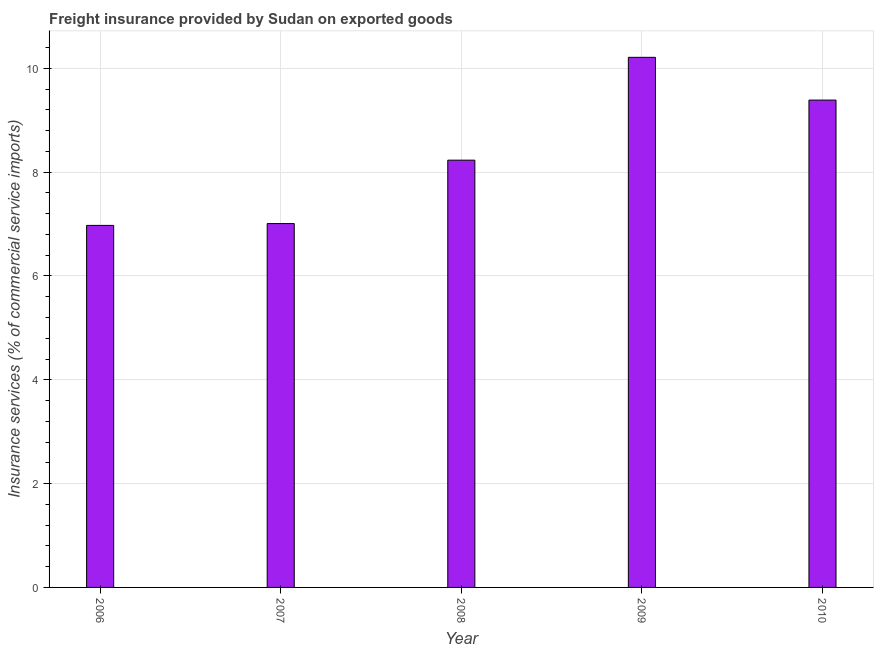Does the graph contain any zero values?
Provide a succinct answer. No. Does the graph contain grids?
Your response must be concise. Yes. What is the title of the graph?
Give a very brief answer. Freight insurance provided by Sudan on exported goods . What is the label or title of the Y-axis?
Give a very brief answer. Insurance services (% of commercial service imports). What is the freight insurance in 2008?
Your response must be concise. 8.23. Across all years, what is the maximum freight insurance?
Provide a short and direct response. 10.21. Across all years, what is the minimum freight insurance?
Your answer should be compact. 6.97. In which year was the freight insurance maximum?
Provide a short and direct response. 2009. In which year was the freight insurance minimum?
Keep it short and to the point. 2006. What is the sum of the freight insurance?
Offer a very short reply. 41.81. What is the difference between the freight insurance in 2009 and 2010?
Offer a very short reply. 0.82. What is the average freight insurance per year?
Offer a terse response. 8.36. What is the median freight insurance?
Your answer should be very brief. 8.23. Do a majority of the years between 2009 and 2007 (inclusive) have freight insurance greater than 5.6 %?
Provide a short and direct response. Yes. What is the ratio of the freight insurance in 2009 to that in 2010?
Ensure brevity in your answer.  1.09. What is the difference between the highest and the second highest freight insurance?
Keep it short and to the point. 0.82. Is the sum of the freight insurance in 2008 and 2010 greater than the maximum freight insurance across all years?
Your response must be concise. Yes. What is the difference between the highest and the lowest freight insurance?
Make the answer very short. 3.24. In how many years, is the freight insurance greater than the average freight insurance taken over all years?
Offer a very short reply. 2. How many bars are there?
Provide a succinct answer. 5. Are all the bars in the graph horizontal?
Provide a succinct answer. No. What is the difference between two consecutive major ticks on the Y-axis?
Give a very brief answer. 2. What is the Insurance services (% of commercial service imports) in 2006?
Make the answer very short. 6.97. What is the Insurance services (% of commercial service imports) of 2007?
Give a very brief answer. 7.01. What is the Insurance services (% of commercial service imports) in 2008?
Make the answer very short. 8.23. What is the Insurance services (% of commercial service imports) in 2009?
Provide a succinct answer. 10.21. What is the Insurance services (% of commercial service imports) in 2010?
Offer a terse response. 9.39. What is the difference between the Insurance services (% of commercial service imports) in 2006 and 2007?
Make the answer very short. -0.04. What is the difference between the Insurance services (% of commercial service imports) in 2006 and 2008?
Your answer should be compact. -1.26. What is the difference between the Insurance services (% of commercial service imports) in 2006 and 2009?
Your answer should be compact. -3.24. What is the difference between the Insurance services (% of commercial service imports) in 2006 and 2010?
Ensure brevity in your answer.  -2.41. What is the difference between the Insurance services (% of commercial service imports) in 2007 and 2008?
Keep it short and to the point. -1.22. What is the difference between the Insurance services (% of commercial service imports) in 2007 and 2009?
Offer a very short reply. -3.2. What is the difference between the Insurance services (% of commercial service imports) in 2007 and 2010?
Ensure brevity in your answer.  -2.38. What is the difference between the Insurance services (% of commercial service imports) in 2008 and 2009?
Your response must be concise. -1.98. What is the difference between the Insurance services (% of commercial service imports) in 2008 and 2010?
Provide a short and direct response. -1.16. What is the difference between the Insurance services (% of commercial service imports) in 2009 and 2010?
Offer a very short reply. 0.82. What is the ratio of the Insurance services (% of commercial service imports) in 2006 to that in 2007?
Make the answer very short. 0.99. What is the ratio of the Insurance services (% of commercial service imports) in 2006 to that in 2008?
Your answer should be very brief. 0.85. What is the ratio of the Insurance services (% of commercial service imports) in 2006 to that in 2009?
Make the answer very short. 0.68. What is the ratio of the Insurance services (% of commercial service imports) in 2006 to that in 2010?
Offer a terse response. 0.74. What is the ratio of the Insurance services (% of commercial service imports) in 2007 to that in 2008?
Your answer should be very brief. 0.85. What is the ratio of the Insurance services (% of commercial service imports) in 2007 to that in 2009?
Provide a short and direct response. 0.69. What is the ratio of the Insurance services (% of commercial service imports) in 2007 to that in 2010?
Your answer should be very brief. 0.75. What is the ratio of the Insurance services (% of commercial service imports) in 2008 to that in 2009?
Offer a terse response. 0.81. What is the ratio of the Insurance services (% of commercial service imports) in 2008 to that in 2010?
Give a very brief answer. 0.88. What is the ratio of the Insurance services (% of commercial service imports) in 2009 to that in 2010?
Your answer should be very brief. 1.09. 